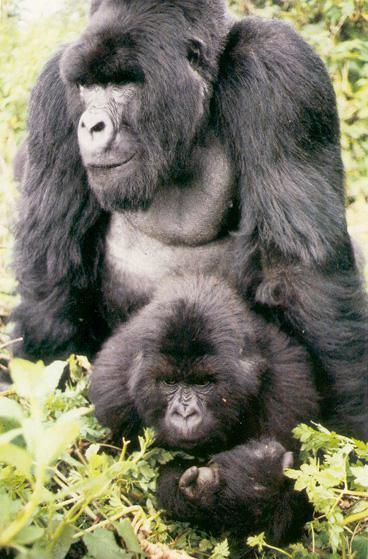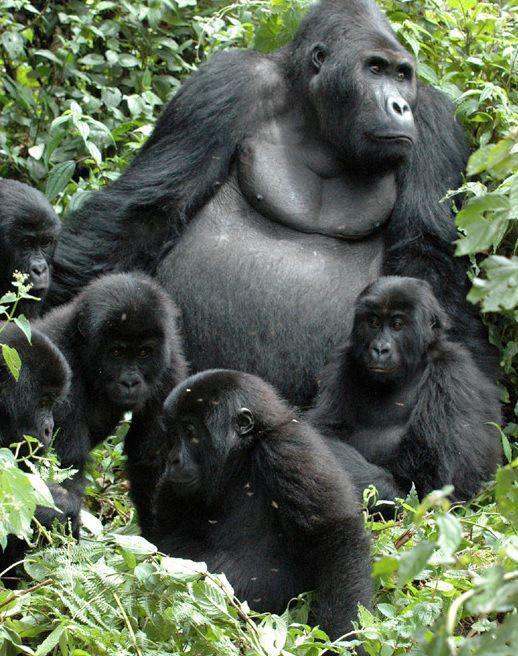The first image is the image on the left, the second image is the image on the right. Analyze the images presented: Is the assertion "One image shows an adult gorilla with two infant gorillas held to its chest." valid? Answer yes or no. No. The first image is the image on the left, the second image is the image on the right. Given the left and right images, does the statement "An adult primate holds two of its young close to its chest in the image on the left." hold true? Answer yes or no. No. 